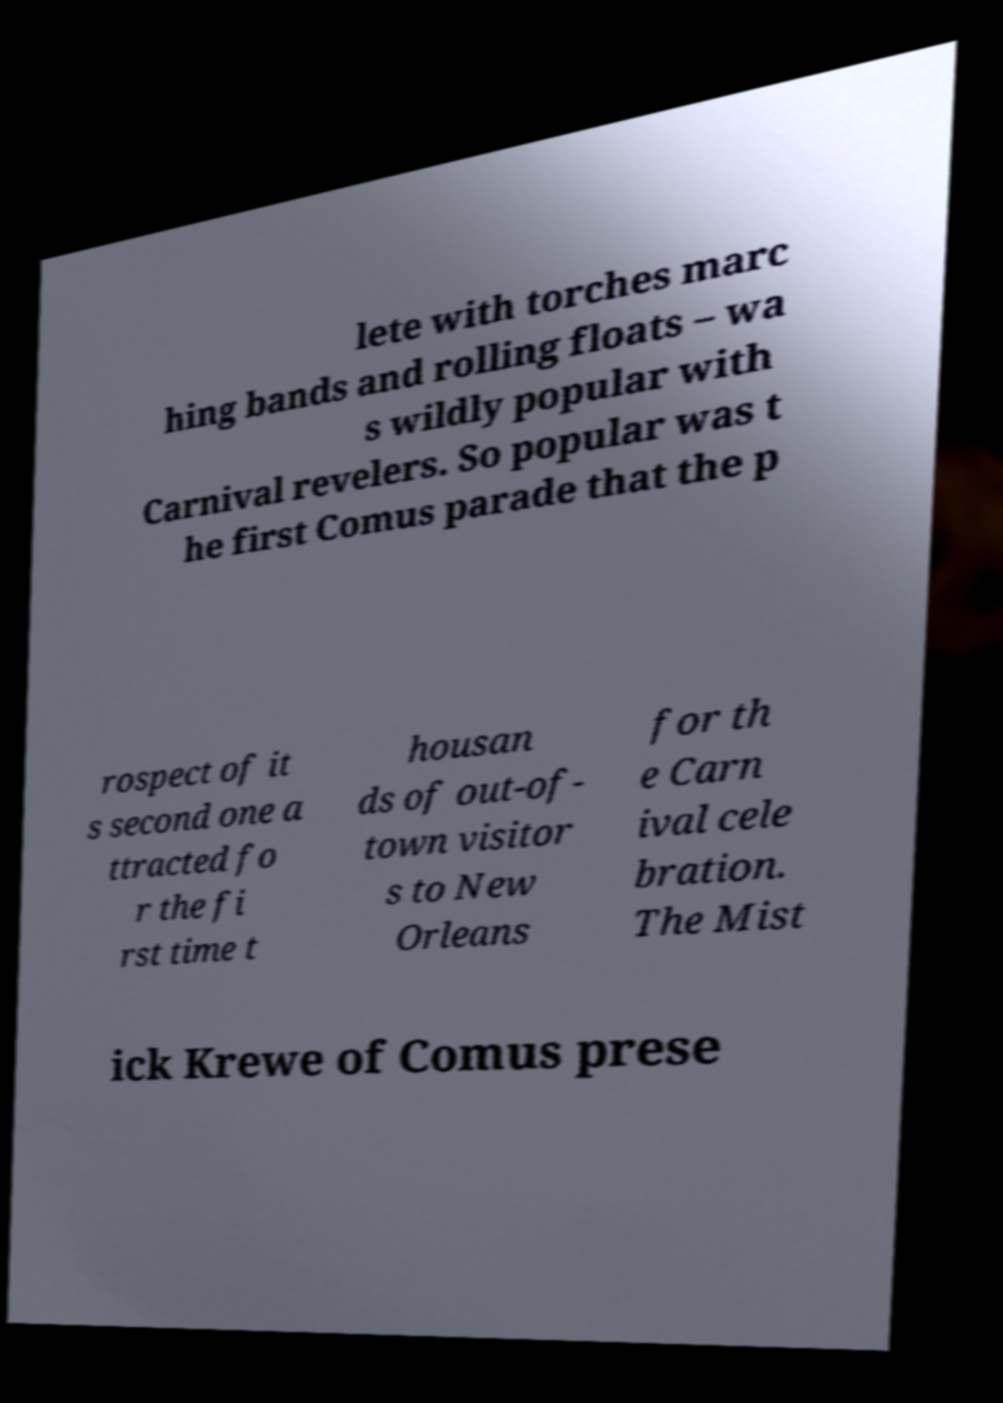Could you assist in decoding the text presented in this image and type it out clearly? lete with torches marc hing bands and rolling floats – wa s wildly popular with Carnival revelers. So popular was t he first Comus parade that the p rospect of it s second one a ttracted fo r the fi rst time t housan ds of out-of- town visitor s to New Orleans for th e Carn ival cele bration. The Mist ick Krewe of Comus prese 